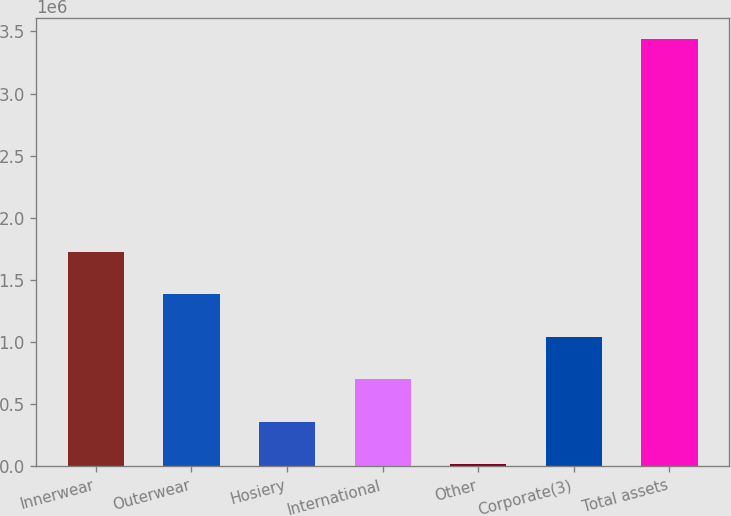Convert chart. <chart><loc_0><loc_0><loc_500><loc_500><bar_chart><fcel>Innerwear<fcel>Outerwear<fcel>Hosiery<fcel>International<fcel>Other<fcel>Corporate(3)<fcel>Total assets<nl><fcel>1.72814e+06<fcel>1.38588e+06<fcel>359075<fcel>701342<fcel>16807<fcel>1.04361e+06<fcel>3.43948e+06<nl></chart> 